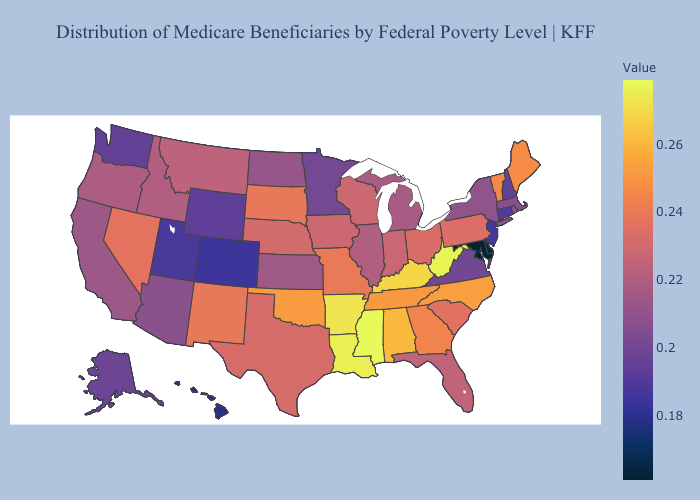Does Hawaii have a lower value than Delaware?
Be succinct. No. Does Mississippi have the highest value in the South?
Be succinct. Yes. Which states have the lowest value in the West?
Concise answer only. Hawaii. Does Rhode Island have a lower value than Utah?
Concise answer only. No. Among the states that border Wisconsin , does Iowa have the lowest value?
Answer briefly. No. Among the states that border Alabama , which have the highest value?
Give a very brief answer. Mississippi. 